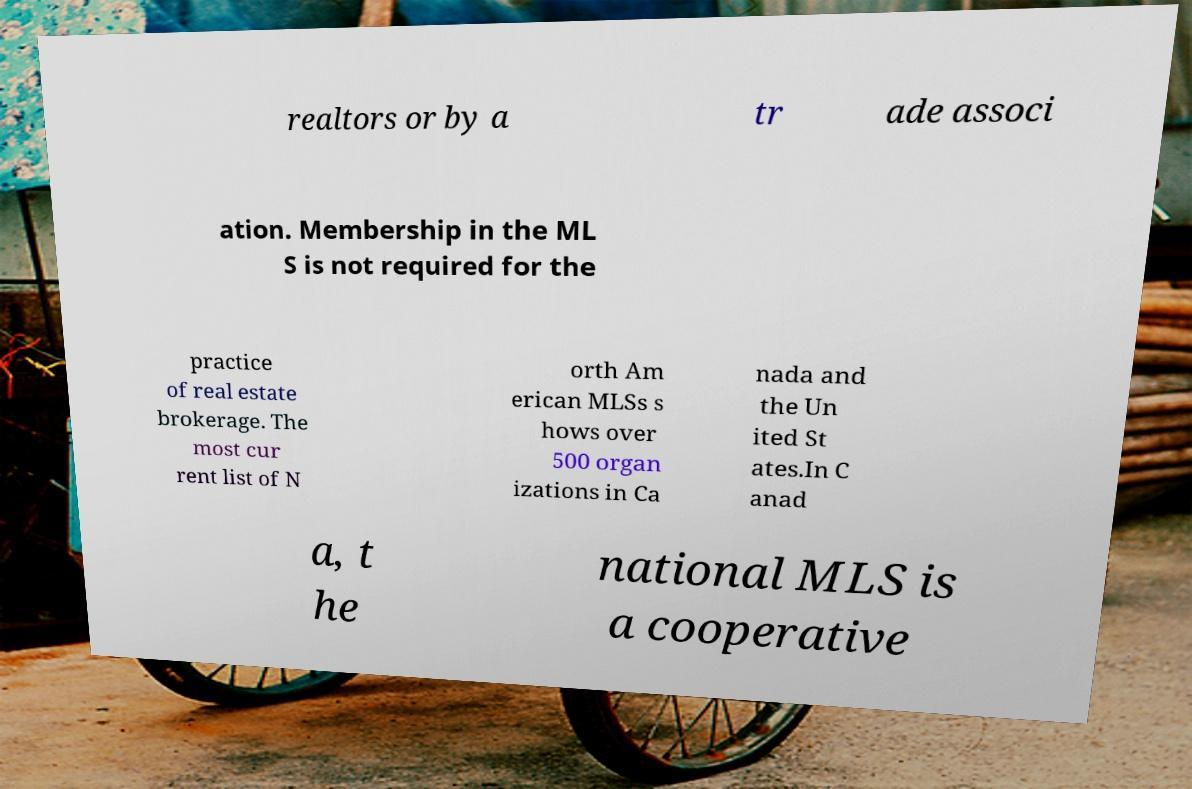Could you extract and type out the text from this image? realtors or by a tr ade associ ation. Membership in the ML S is not required for the practice of real estate brokerage. The most cur rent list of N orth Am erican MLSs s hows over 500 organ izations in Ca nada and the Un ited St ates.In C anad a, t he national MLS is a cooperative 